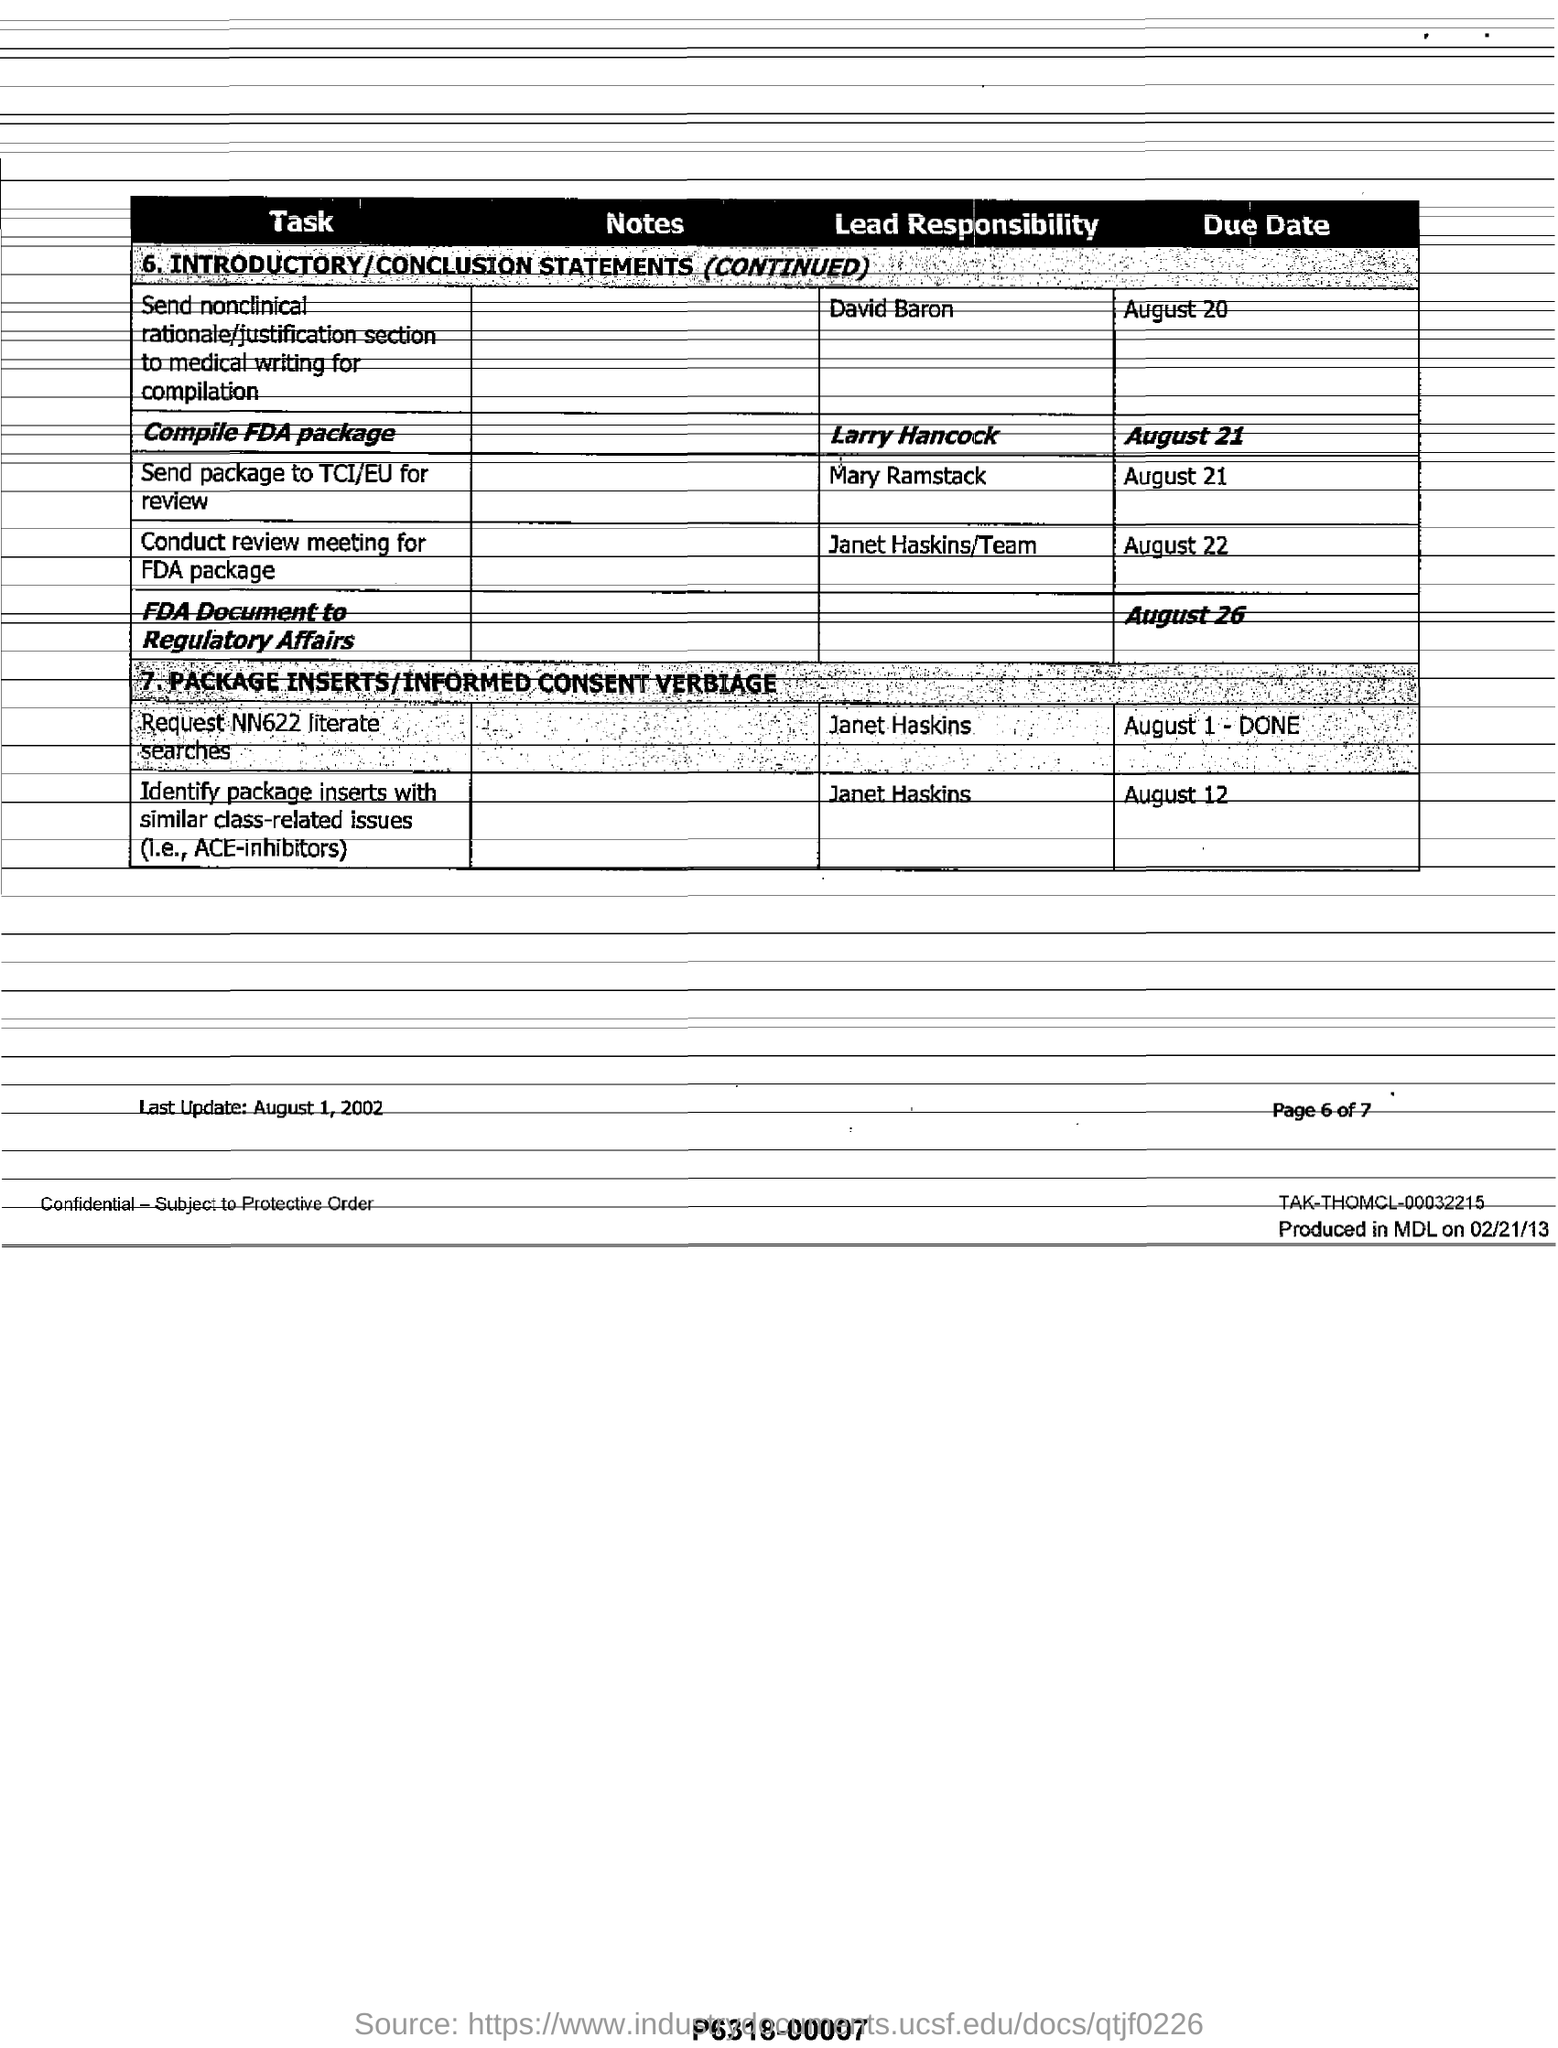What is the due date to conduct review meeting for FDA package?
Offer a very short reply. August 22. Who is the lead responsible person for the  compilation of FDA package?
Your answer should be compact. Larry Hancock. What is the task assigned to David Baron?
Your answer should be compact. Send nonclinical rationale/justification section to medical writing for compilation. Who is responsible for sending  package to TCI/EU for review?
Offer a terse response. Mary Ramstack. What is the due date for sending FDA Document to Regulatory Affairs?
Keep it short and to the point. August 26. What is the last updated date mentioned in this document?
Make the answer very short. August 1,  2002. 